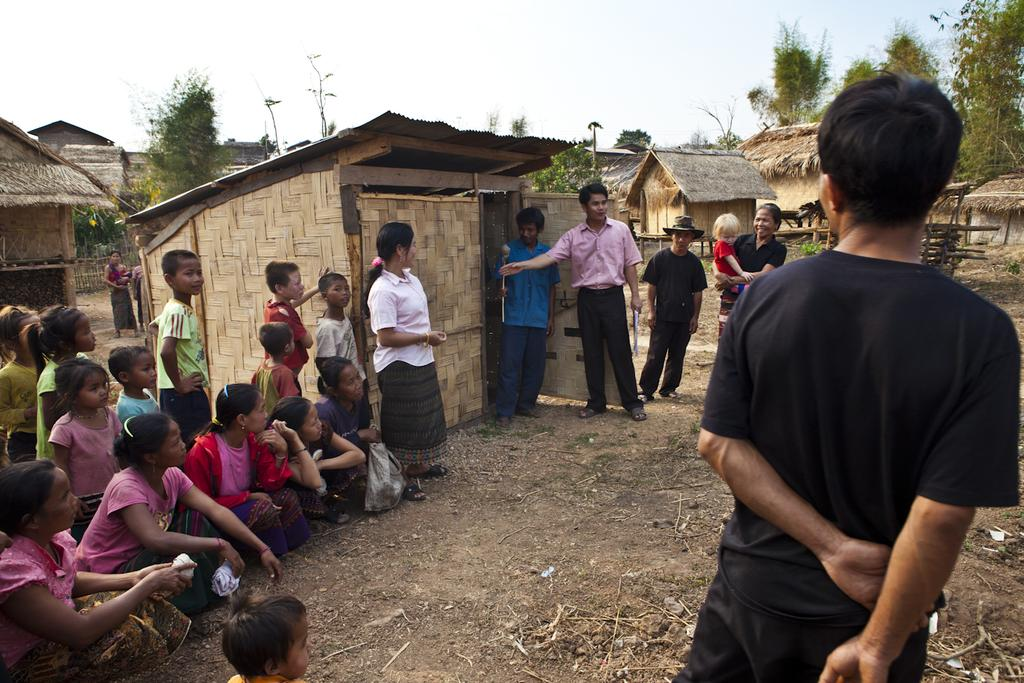Who or what can be seen in the image? There are people in the image. What type of structures are visible in the image? There are huts in the image. What other natural elements can be seen in the image? There are trees in the image. What is visible in the background of the image? The sky is visible in the background of the image. What color is the thumb of the person in the image? There is no thumb visible in the image, as it only shows people, huts, trees, and the sky. 